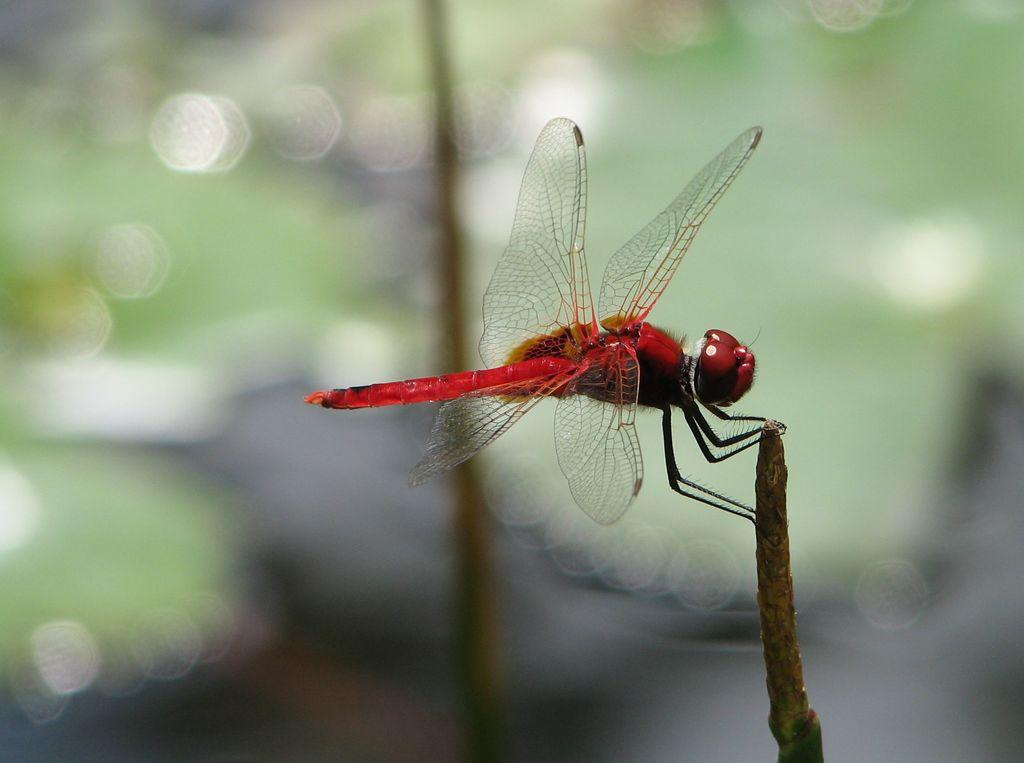What is the main subject of the picture? The main subject of the picture is a dragonfly. Where is the dragonfly located in the image? The dragonfly is on a stem in the image. Can you describe the background of the image? The background of the image is blurred. What type of cream can be seen in the dragonfly's cell in the image? There is no cream or cell present in the image, as it features a dragonfly on a stem with a blurred background. 